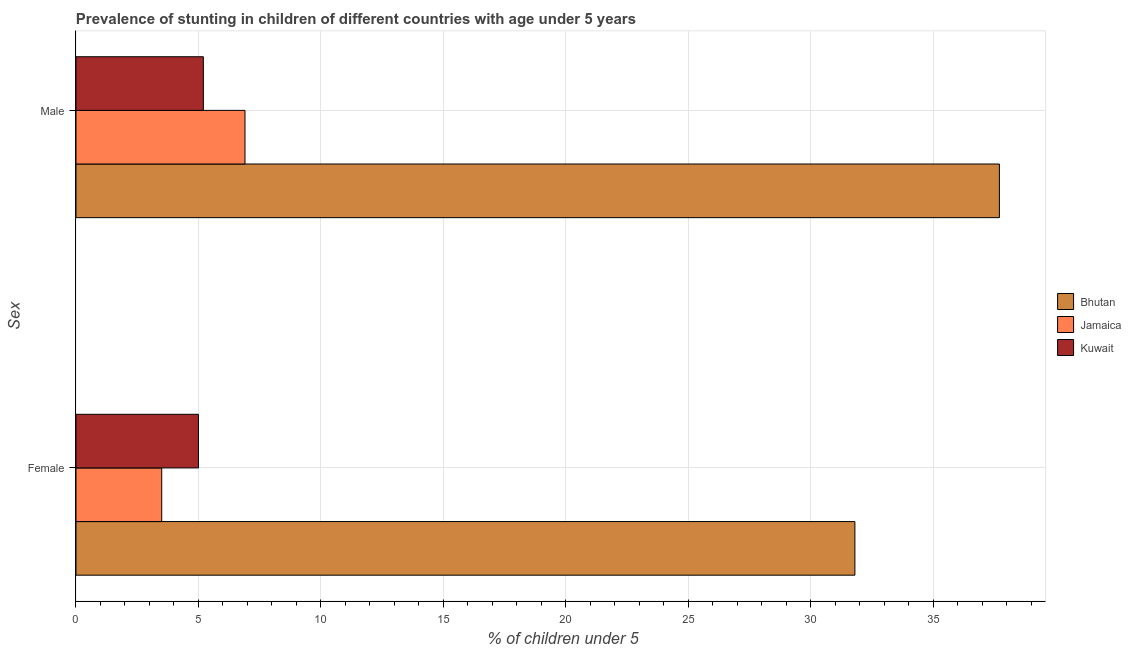How many different coloured bars are there?
Your response must be concise. 3. How many groups of bars are there?
Offer a very short reply. 2. Are the number of bars per tick equal to the number of legend labels?
Make the answer very short. Yes. How many bars are there on the 2nd tick from the top?
Provide a short and direct response. 3. What is the percentage of stunted male children in Kuwait?
Your answer should be very brief. 5.2. Across all countries, what is the maximum percentage of stunted male children?
Provide a succinct answer. 37.7. Across all countries, what is the minimum percentage of stunted male children?
Give a very brief answer. 5.2. In which country was the percentage of stunted female children maximum?
Your response must be concise. Bhutan. In which country was the percentage of stunted male children minimum?
Give a very brief answer. Kuwait. What is the total percentage of stunted female children in the graph?
Your answer should be compact. 40.3. What is the difference between the percentage of stunted female children in Kuwait and that in Jamaica?
Keep it short and to the point. 1.5. What is the difference between the percentage of stunted female children in Kuwait and the percentage of stunted male children in Jamaica?
Provide a succinct answer. -1.9. What is the average percentage of stunted male children per country?
Give a very brief answer. 16.6. What is the difference between the percentage of stunted female children and percentage of stunted male children in Jamaica?
Give a very brief answer. -3.4. What is the ratio of the percentage of stunted male children in Jamaica to that in Bhutan?
Keep it short and to the point. 0.18. Is the percentage of stunted male children in Jamaica less than that in Bhutan?
Make the answer very short. Yes. What does the 3rd bar from the top in Male represents?
Offer a terse response. Bhutan. What does the 3rd bar from the bottom in Female represents?
Offer a terse response. Kuwait. How many bars are there?
Ensure brevity in your answer.  6. Are all the bars in the graph horizontal?
Offer a very short reply. Yes. How many countries are there in the graph?
Make the answer very short. 3. What is the difference between two consecutive major ticks on the X-axis?
Keep it short and to the point. 5. Does the graph contain grids?
Give a very brief answer. Yes. How many legend labels are there?
Your answer should be compact. 3. How are the legend labels stacked?
Provide a short and direct response. Vertical. What is the title of the graph?
Offer a terse response. Prevalence of stunting in children of different countries with age under 5 years. What is the label or title of the X-axis?
Your response must be concise.  % of children under 5. What is the label or title of the Y-axis?
Provide a succinct answer. Sex. What is the  % of children under 5 in Bhutan in Female?
Keep it short and to the point. 31.8. What is the  % of children under 5 of Bhutan in Male?
Provide a succinct answer. 37.7. What is the  % of children under 5 of Jamaica in Male?
Offer a terse response. 6.9. What is the  % of children under 5 of Kuwait in Male?
Offer a very short reply. 5.2. Across all Sex, what is the maximum  % of children under 5 in Bhutan?
Provide a succinct answer. 37.7. Across all Sex, what is the maximum  % of children under 5 of Jamaica?
Ensure brevity in your answer.  6.9. Across all Sex, what is the maximum  % of children under 5 of Kuwait?
Provide a short and direct response. 5.2. Across all Sex, what is the minimum  % of children under 5 in Bhutan?
Your answer should be compact. 31.8. What is the total  % of children under 5 of Bhutan in the graph?
Offer a terse response. 69.5. What is the total  % of children under 5 of Jamaica in the graph?
Provide a succinct answer. 10.4. What is the total  % of children under 5 in Kuwait in the graph?
Offer a terse response. 10.2. What is the difference between the  % of children under 5 in Bhutan in Female and that in Male?
Ensure brevity in your answer.  -5.9. What is the difference between the  % of children under 5 in Bhutan in Female and the  % of children under 5 in Jamaica in Male?
Give a very brief answer. 24.9. What is the difference between the  % of children under 5 of Bhutan in Female and the  % of children under 5 of Kuwait in Male?
Keep it short and to the point. 26.6. What is the difference between the  % of children under 5 in Jamaica in Female and the  % of children under 5 in Kuwait in Male?
Your answer should be compact. -1.7. What is the average  % of children under 5 of Bhutan per Sex?
Your response must be concise. 34.75. What is the average  % of children under 5 of Jamaica per Sex?
Give a very brief answer. 5.2. What is the difference between the  % of children under 5 of Bhutan and  % of children under 5 of Jamaica in Female?
Provide a succinct answer. 28.3. What is the difference between the  % of children under 5 of Bhutan and  % of children under 5 of Kuwait in Female?
Give a very brief answer. 26.8. What is the difference between the  % of children under 5 in Bhutan and  % of children under 5 in Jamaica in Male?
Your answer should be very brief. 30.8. What is the difference between the  % of children under 5 in Bhutan and  % of children under 5 in Kuwait in Male?
Provide a short and direct response. 32.5. What is the difference between the  % of children under 5 of Jamaica and  % of children under 5 of Kuwait in Male?
Ensure brevity in your answer.  1.7. What is the ratio of the  % of children under 5 of Bhutan in Female to that in Male?
Keep it short and to the point. 0.84. What is the ratio of the  % of children under 5 of Jamaica in Female to that in Male?
Make the answer very short. 0.51. What is the ratio of the  % of children under 5 in Kuwait in Female to that in Male?
Offer a very short reply. 0.96. What is the difference between the highest and the second highest  % of children under 5 in Bhutan?
Ensure brevity in your answer.  5.9. What is the difference between the highest and the lowest  % of children under 5 in Bhutan?
Provide a succinct answer. 5.9. What is the difference between the highest and the lowest  % of children under 5 of Jamaica?
Give a very brief answer. 3.4. What is the difference between the highest and the lowest  % of children under 5 in Kuwait?
Your answer should be very brief. 0.2. 